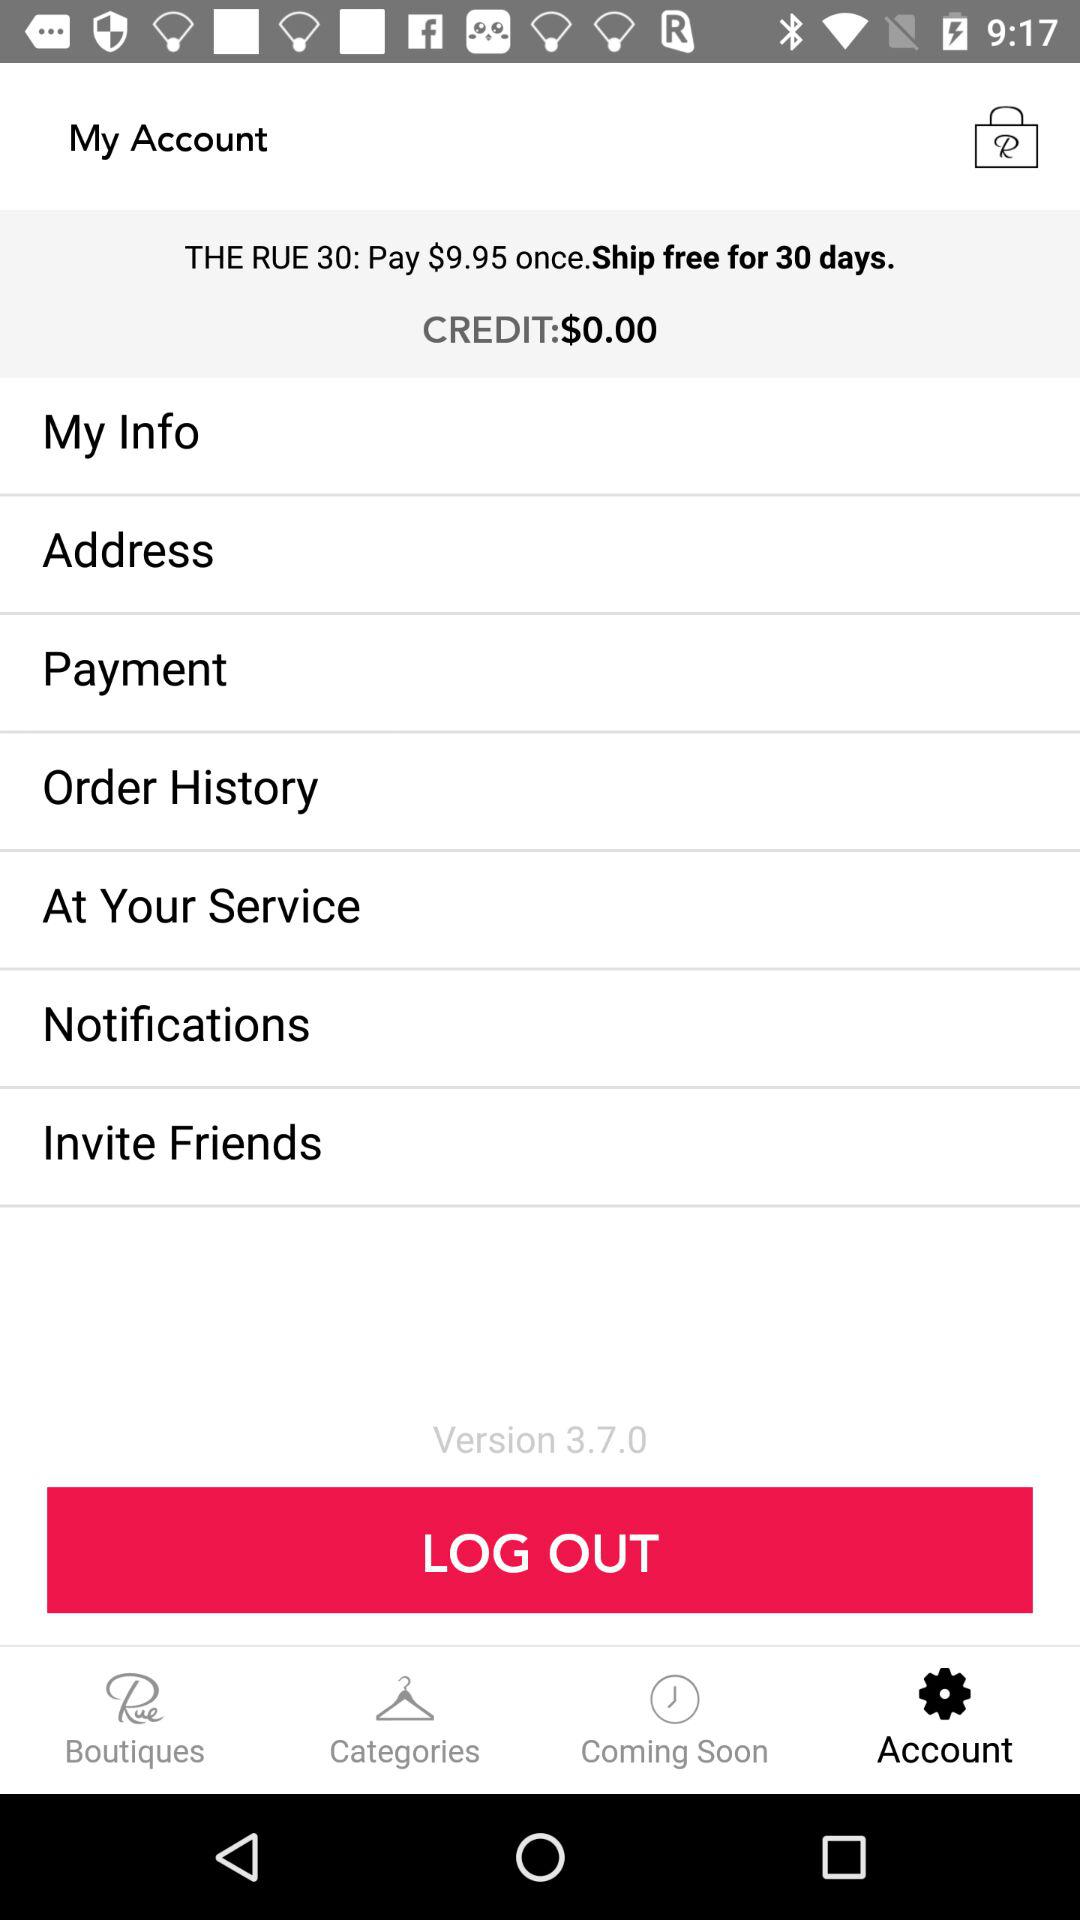For how many days is shipping free once an amount is paid? The shipping is free for 30 days. 